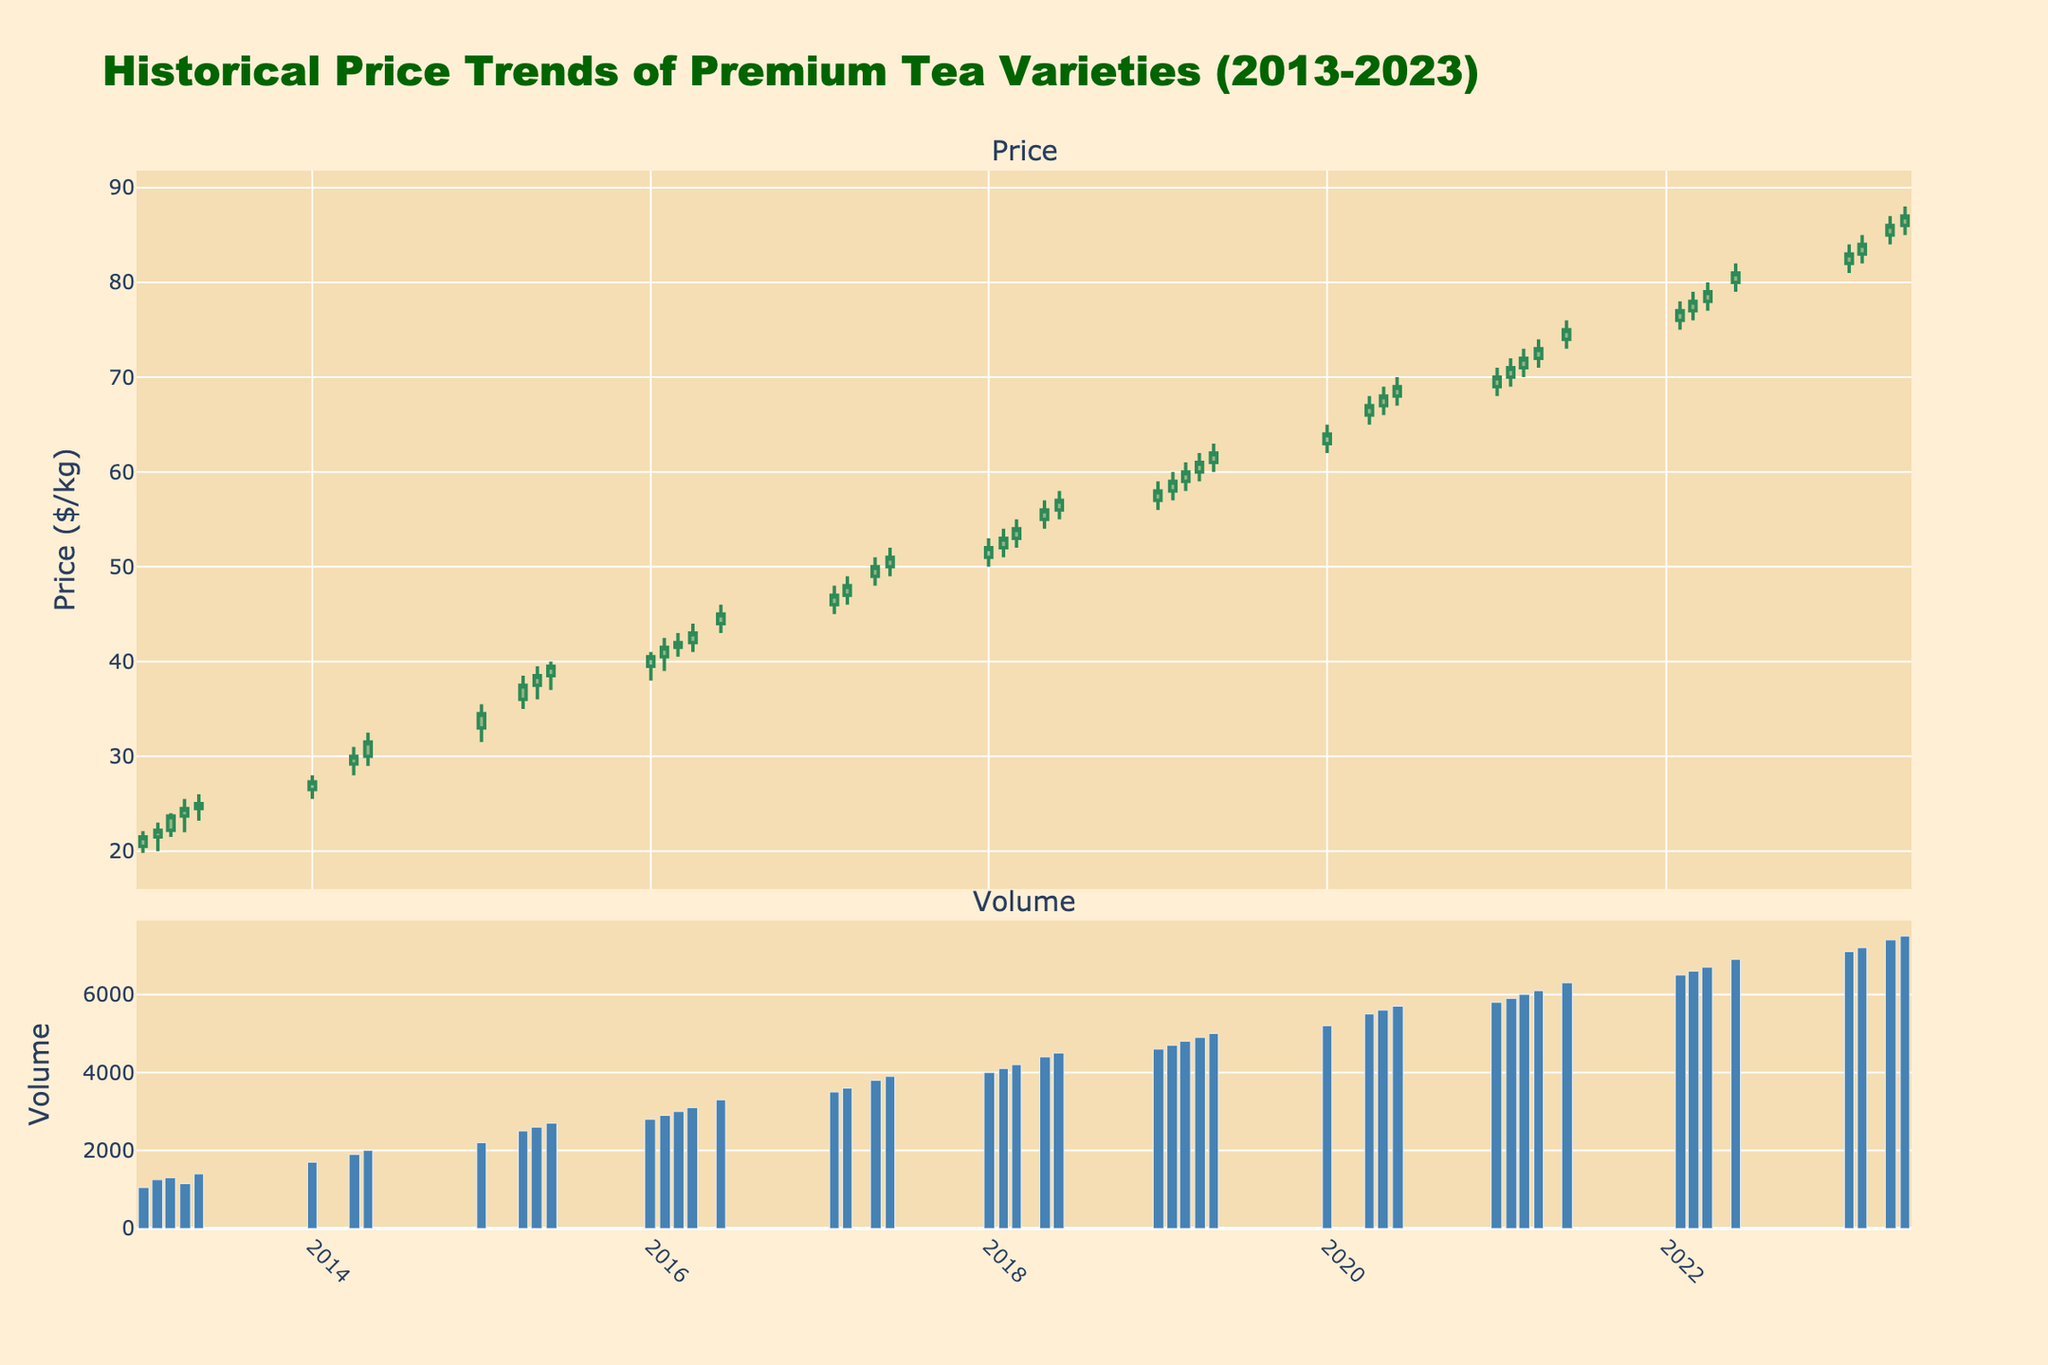What's the title of the figure? The title of the figure is usually found at the top center and is meant to summarize the content of the plot. In this case, it reads 'Historical Price Trends of Premium Tea Varieties (2013-2023)'.
Answer: Historical Price Trends of Premium Tea Varieties (2013-2023) How many data points are plotted for Volume in 2018? Each data point in the Volume chart corresponds to a month. Since the data is monthly and only covers the months until June, there are 6 data points (one for each month: January to June).
Answer: 6 What is the highest price recorded in 2014 and in which month? To find the highest price recorded in 2014, look at the 'High' values in the candlestick chart for the year 2014 and identify the highest one, which is in June with a peak of $34.00.
Answer: June What was the closing price of tea in June 2015? To find the closing price of tea for a given month, locate the specific month on the candlestick chart and read the 'Close' value. For June 2015, the closing price is $39.50.
Answer: $39.50 In which month of 2017 was the Volume the highest, and what is the value? To determine the month with the highest volume in 2017, examine the bar chart for volume in that year. The bar for June is the tallest, indicating the highest volume of 3900.
Answer: June, 3900 How does the opening price in January 2020 compare to July 2020? Compare the 'Open' values in the candlestick chart for January and July 2020. January's opening price is $63.00, while for July we don't have data; comparing available months requires checking January and June.
Answer: January: $63.00, July: (not available) Between which two consecutive months in 2013 did the price see its largest increase, and what was the increase amount? Look at the 'Close' prices for consecutive months in 2013, and calculate the differences: Feb-Mar ($23.70 - $22.20 = $1.50), Mar-Apr ($24.50 - $23.70 = $0.80), etc. The largest increase is from March to April with an increase of $1.50.
Answer: March to April, $1.50 What is the average closing price for tea in the whole dataset? Sum all the 'Close' prices listed in the dataset and then divide by the total number of data points. Sum of all Closings (total expanded) divided by number of months (66).
Answer: $54.18 When was the last recorded price change and what was the close value? The last recorded price change is seen at the end of the dataset, at June 2023, where the closing price is stated.
Answer: June 2023, $87.00 